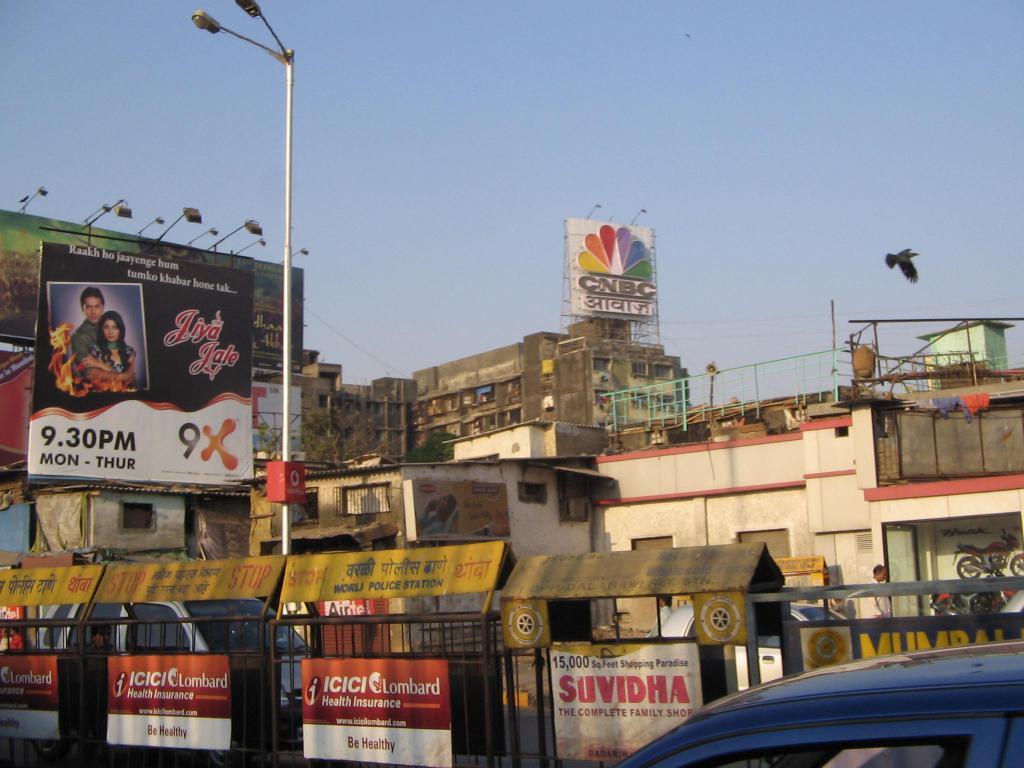The sign says monday through when?
Offer a very short reply. Thursday. What tv channel is being advertised in the background?
Offer a very short reply. Cnbc. 